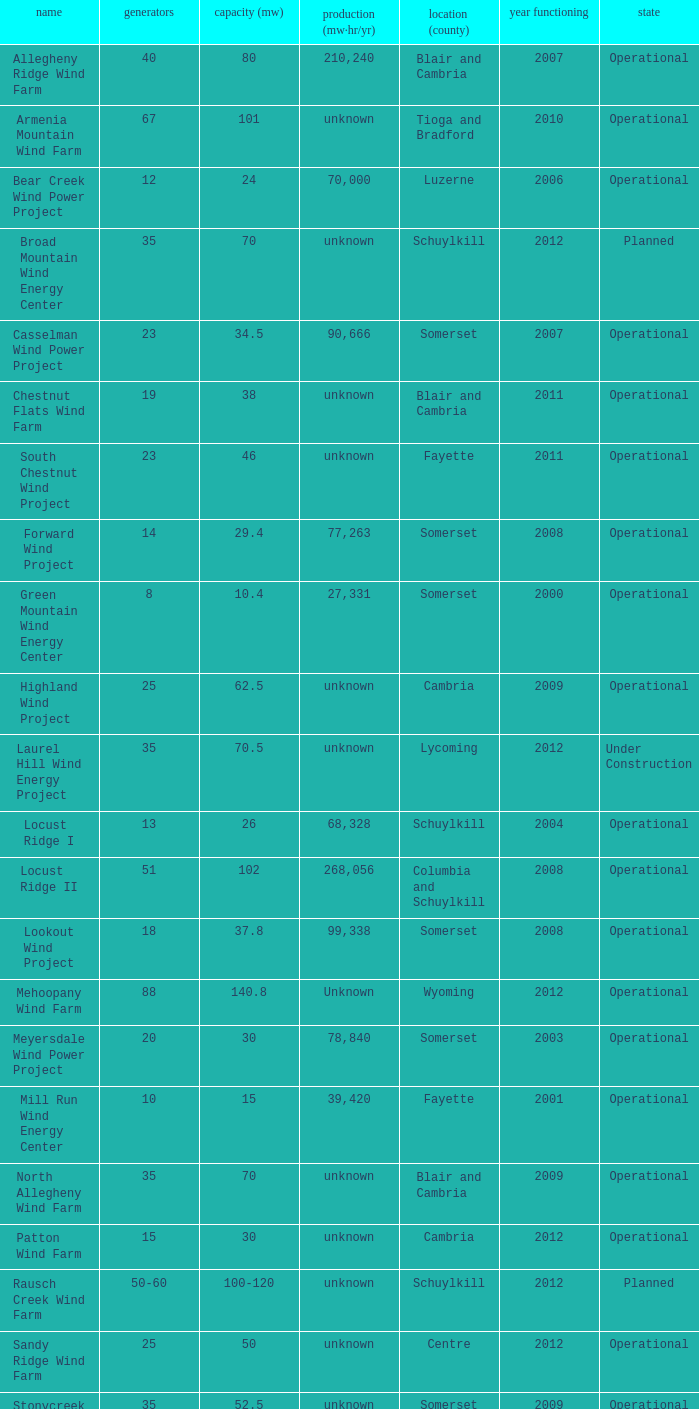What all turbines have a capacity of 30 and have a Somerset location? 20.0. 